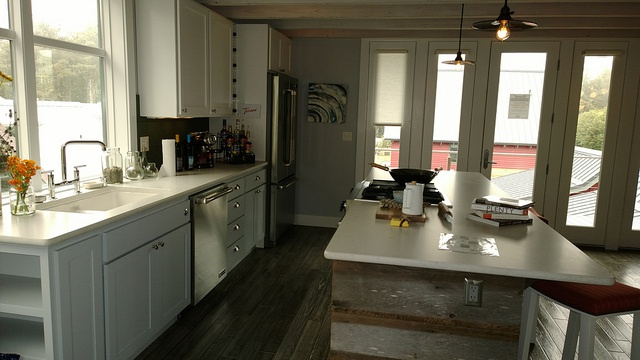Describe the objects in this image and their specific colors. I can see dining table in white, gray, and darkgray tones, chair in white, black, gray, and maroon tones, refrigerator in white, black, darkgreen, olive, and gray tones, oven in white, gray, black, and darkgreen tones, and sink in white, tan, and beige tones in this image. 